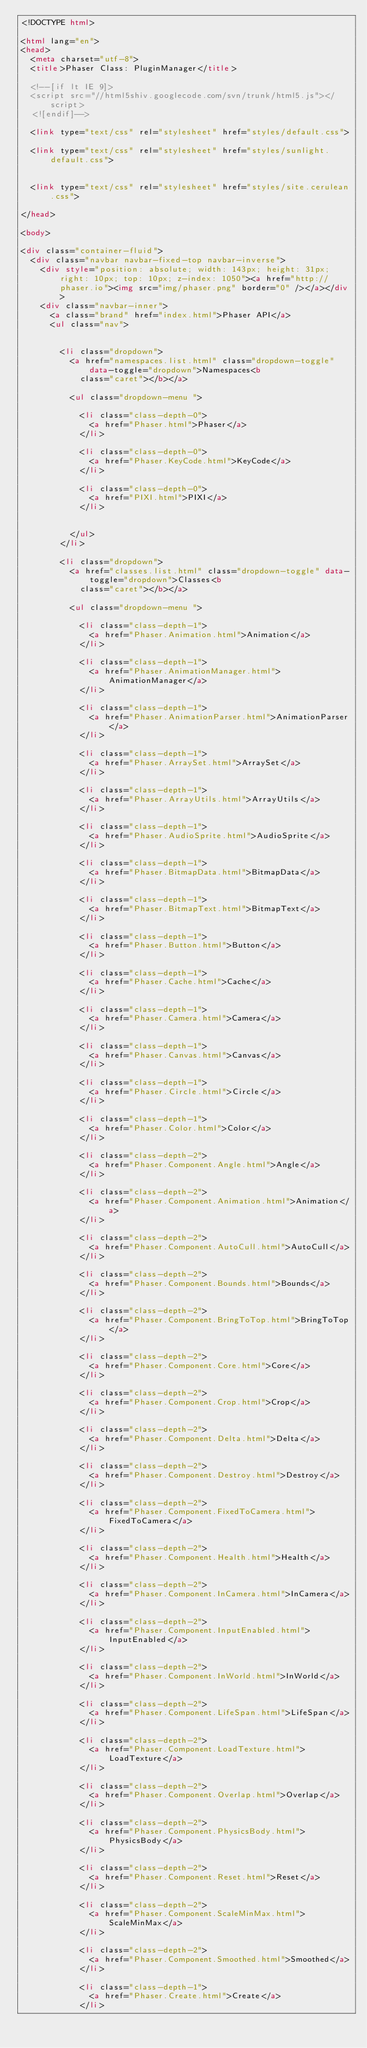<code> <loc_0><loc_0><loc_500><loc_500><_HTML_><!DOCTYPE html>

<html lang="en">
<head>
	<meta charset="utf-8">
	<title>Phaser Class: PluginManager</title>

	<!--[if lt IE 9]>
	<script src="//html5shiv.googlecode.com/svn/trunk/html5.js"></script>
	<![endif]-->

	<link type="text/css" rel="stylesheet" href="styles/default.css">

	<link type="text/css" rel="stylesheet" href="styles/sunlight.default.css">

	
	<link type="text/css" rel="stylesheet" href="styles/site.cerulean.css">
	
</head>

<body>

<div class="container-fluid">
	<div class="navbar navbar-fixed-top navbar-inverse">
		<div style="position: absolute; width: 143px; height: 31px; right: 10px; top: 10px; z-index: 1050"><a href="http://phaser.io"><img src="img/phaser.png" border="0" /></a></div>
		<div class="navbar-inner">
			<a class="brand" href="index.html">Phaser API</a>
			<ul class="nav">

				
				<li class="dropdown">
					<a href="namespaces.list.html" class="dropdown-toggle" data-toggle="dropdown">Namespaces<b
						class="caret"></b></a>

					<ul class="dropdown-menu ">
						
						<li class="class-depth-0">
							<a href="Phaser.html">Phaser</a>
						</li>
						
						<li class="class-depth-0">
							<a href="Phaser.KeyCode.html">KeyCode</a>
						</li>
						
						<li class="class-depth-0">
							<a href="PIXI.html">PIXI</a>
						</li>
						

					</ul>
				</li>
				
				<li class="dropdown">
					<a href="classes.list.html" class="dropdown-toggle" data-toggle="dropdown">Classes<b
						class="caret"></b></a>

					<ul class="dropdown-menu ">
						
						<li class="class-depth-1">
							<a href="Phaser.Animation.html">Animation</a>
						</li>
						
						<li class="class-depth-1">
							<a href="Phaser.AnimationManager.html">AnimationManager</a>
						</li>
						
						<li class="class-depth-1">
							<a href="Phaser.AnimationParser.html">AnimationParser</a>
						</li>
						
						<li class="class-depth-1">
							<a href="Phaser.ArraySet.html">ArraySet</a>
						</li>
						
						<li class="class-depth-1">
							<a href="Phaser.ArrayUtils.html">ArrayUtils</a>
						</li>
						
						<li class="class-depth-1">
							<a href="Phaser.AudioSprite.html">AudioSprite</a>
						</li>
						
						<li class="class-depth-1">
							<a href="Phaser.BitmapData.html">BitmapData</a>
						</li>
						
						<li class="class-depth-1">
							<a href="Phaser.BitmapText.html">BitmapText</a>
						</li>
						
						<li class="class-depth-1">
							<a href="Phaser.Button.html">Button</a>
						</li>
						
						<li class="class-depth-1">
							<a href="Phaser.Cache.html">Cache</a>
						</li>
						
						<li class="class-depth-1">
							<a href="Phaser.Camera.html">Camera</a>
						</li>
						
						<li class="class-depth-1">
							<a href="Phaser.Canvas.html">Canvas</a>
						</li>
						
						<li class="class-depth-1">
							<a href="Phaser.Circle.html">Circle</a>
						</li>
						
						<li class="class-depth-1">
							<a href="Phaser.Color.html">Color</a>
						</li>
						
						<li class="class-depth-2">
							<a href="Phaser.Component.Angle.html">Angle</a>
						</li>
						
						<li class="class-depth-2">
							<a href="Phaser.Component.Animation.html">Animation</a>
						</li>
						
						<li class="class-depth-2">
							<a href="Phaser.Component.AutoCull.html">AutoCull</a>
						</li>
						
						<li class="class-depth-2">
							<a href="Phaser.Component.Bounds.html">Bounds</a>
						</li>
						
						<li class="class-depth-2">
							<a href="Phaser.Component.BringToTop.html">BringToTop</a>
						</li>
						
						<li class="class-depth-2">
							<a href="Phaser.Component.Core.html">Core</a>
						</li>
						
						<li class="class-depth-2">
							<a href="Phaser.Component.Crop.html">Crop</a>
						</li>
						
						<li class="class-depth-2">
							<a href="Phaser.Component.Delta.html">Delta</a>
						</li>
						
						<li class="class-depth-2">
							<a href="Phaser.Component.Destroy.html">Destroy</a>
						</li>
						
						<li class="class-depth-2">
							<a href="Phaser.Component.FixedToCamera.html">FixedToCamera</a>
						</li>
						
						<li class="class-depth-2">
							<a href="Phaser.Component.Health.html">Health</a>
						</li>
						
						<li class="class-depth-2">
							<a href="Phaser.Component.InCamera.html">InCamera</a>
						</li>
						
						<li class="class-depth-2">
							<a href="Phaser.Component.InputEnabled.html">InputEnabled</a>
						</li>
						
						<li class="class-depth-2">
							<a href="Phaser.Component.InWorld.html">InWorld</a>
						</li>
						
						<li class="class-depth-2">
							<a href="Phaser.Component.LifeSpan.html">LifeSpan</a>
						</li>
						
						<li class="class-depth-2">
							<a href="Phaser.Component.LoadTexture.html">LoadTexture</a>
						</li>
						
						<li class="class-depth-2">
							<a href="Phaser.Component.Overlap.html">Overlap</a>
						</li>
						
						<li class="class-depth-2">
							<a href="Phaser.Component.PhysicsBody.html">PhysicsBody</a>
						</li>
						
						<li class="class-depth-2">
							<a href="Phaser.Component.Reset.html">Reset</a>
						</li>
						
						<li class="class-depth-2">
							<a href="Phaser.Component.ScaleMinMax.html">ScaleMinMax</a>
						</li>
						
						<li class="class-depth-2">
							<a href="Phaser.Component.Smoothed.html">Smoothed</a>
						</li>
						
						<li class="class-depth-1">
							<a href="Phaser.Create.html">Create</a>
						</li>
						</code> 